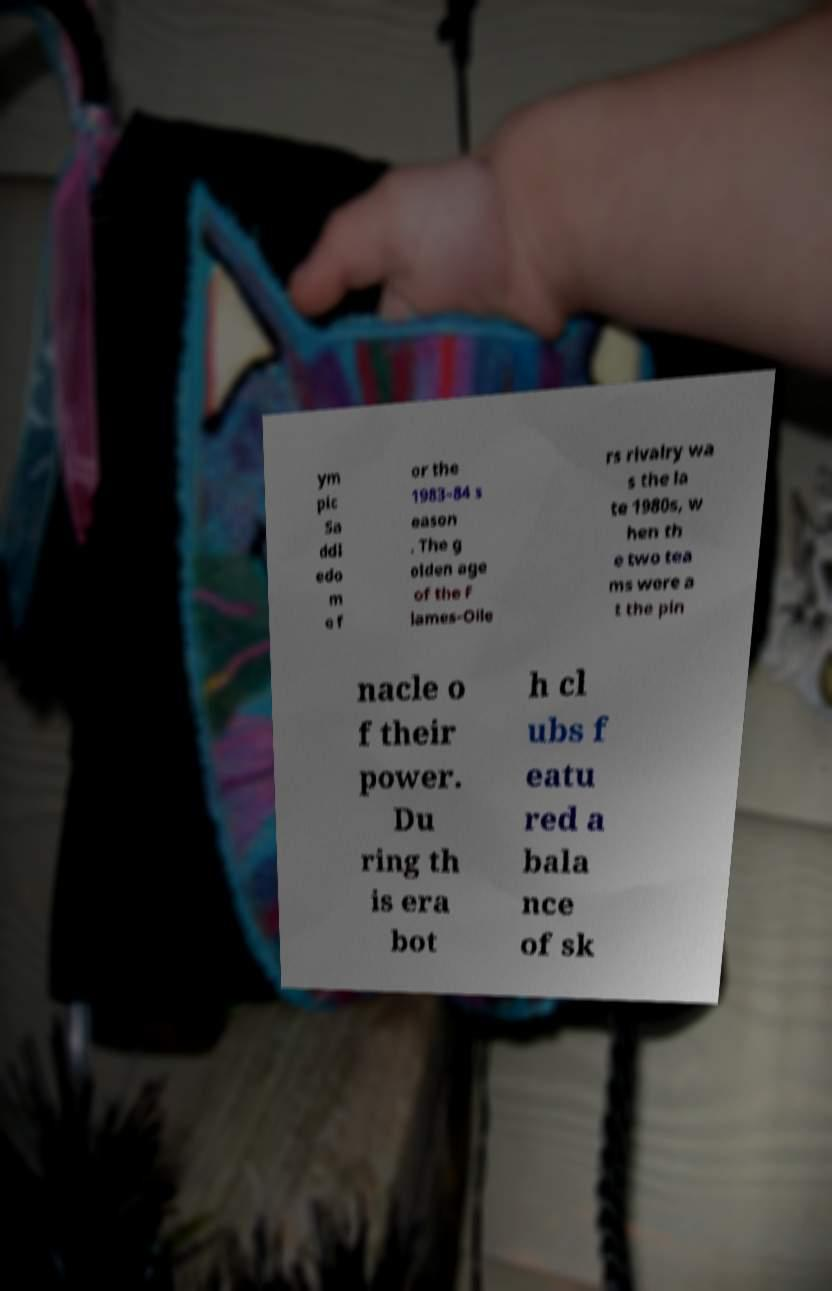Could you extract and type out the text from this image? ym pic Sa ddl edo m e f or the 1983–84 s eason . The g olden age of the F lames-Oile rs rivalry wa s the la te 1980s, w hen th e two tea ms were a t the pin nacle o f their power. Du ring th is era bot h cl ubs f eatu red a bala nce of sk 